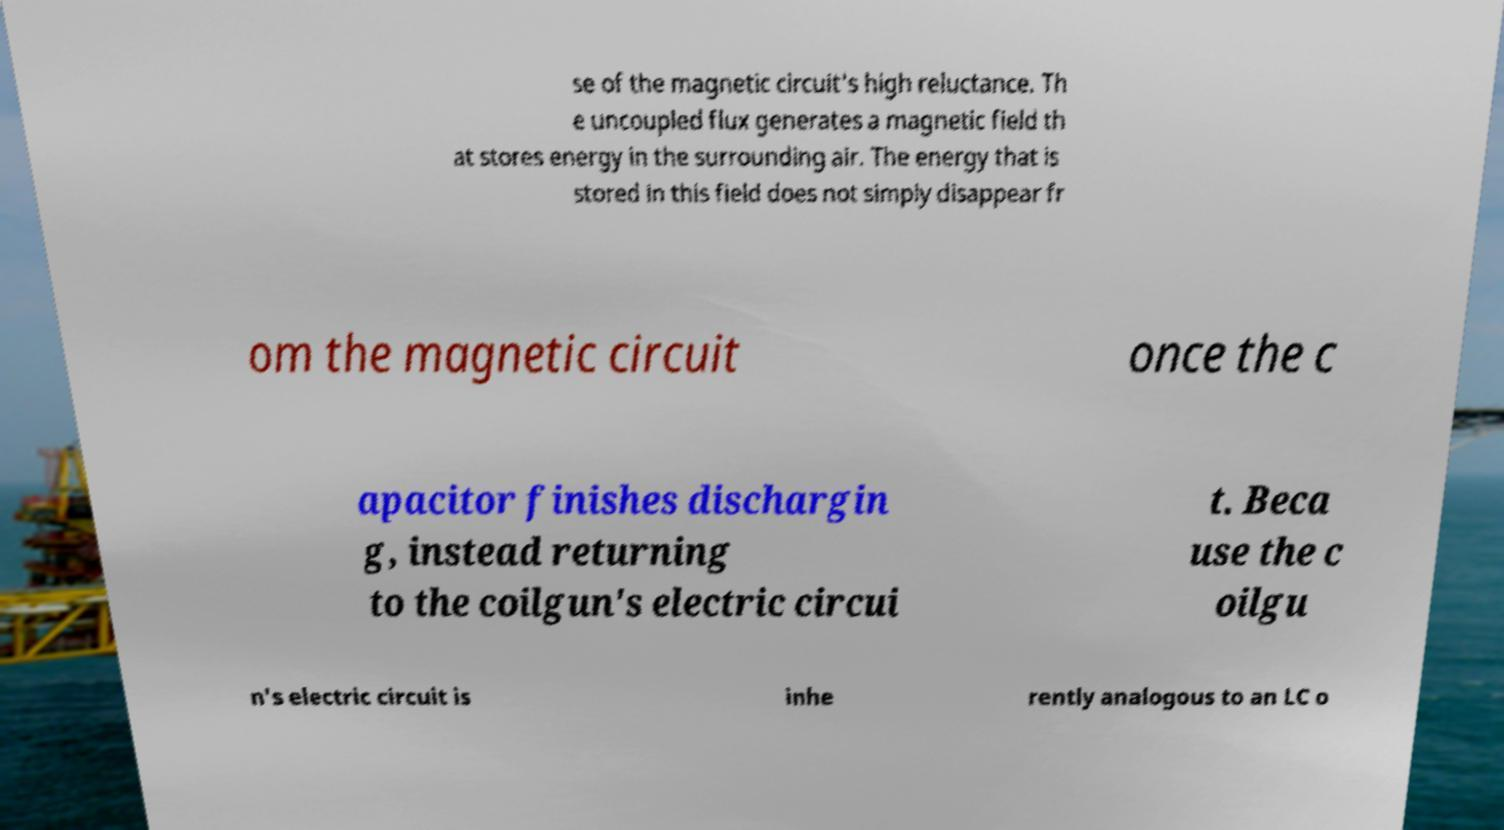Could you assist in decoding the text presented in this image and type it out clearly? se of the magnetic circuit's high reluctance. Th e uncoupled flux generates a magnetic field th at stores energy in the surrounding air. The energy that is stored in this field does not simply disappear fr om the magnetic circuit once the c apacitor finishes dischargin g, instead returning to the coilgun's electric circui t. Beca use the c oilgu n's electric circuit is inhe rently analogous to an LC o 